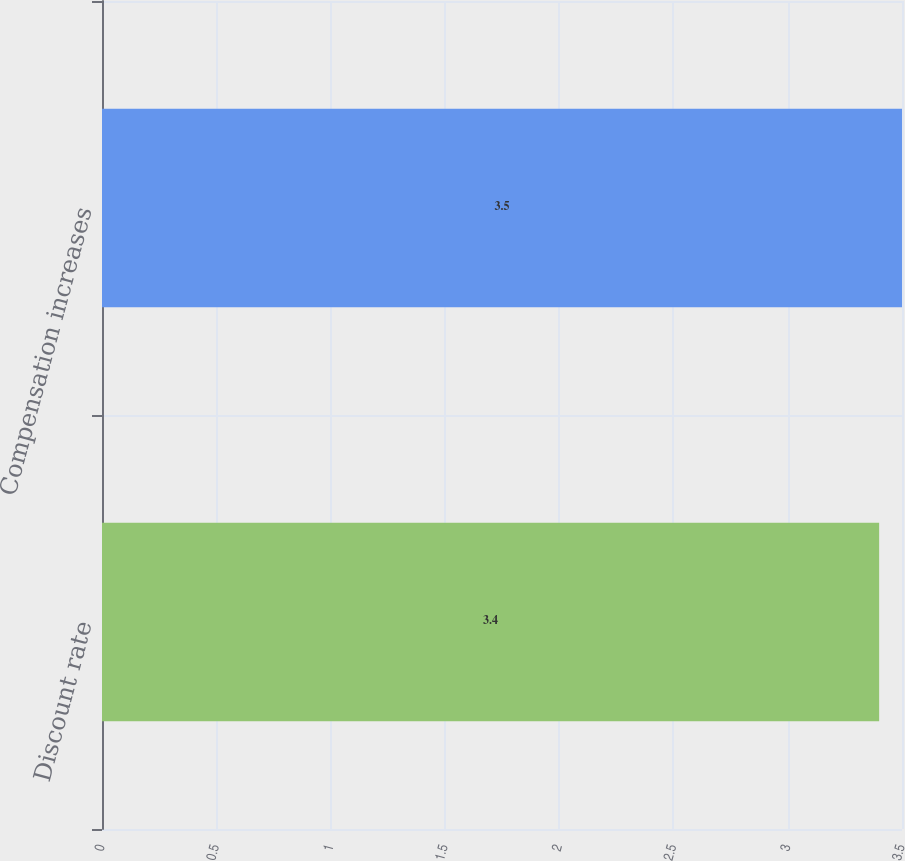Convert chart to OTSL. <chart><loc_0><loc_0><loc_500><loc_500><bar_chart><fcel>Discount rate<fcel>Compensation increases<nl><fcel>3.4<fcel>3.5<nl></chart> 